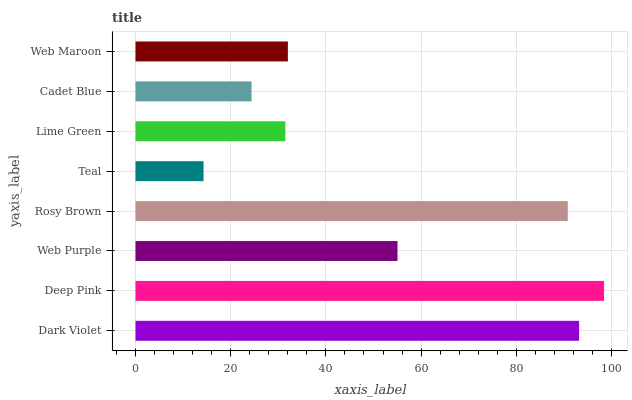Is Teal the minimum?
Answer yes or no. Yes. Is Deep Pink the maximum?
Answer yes or no. Yes. Is Web Purple the minimum?
Answer yes or no. No. Is Web Purple the maximum?
Answer yes or no. No. Is Deep Pink greater than Web Purple?
Answer yes or no. Yes. Is Web Purple less than Deep Pink?
Answer yes or no. Yes. Is Web Purple greater than Deep Pink?
Answer yes or no. No. Is Deep Pink less than Web Purple?
Answer yes or no. No. Is Web Purple the high median?
Answer yes or no. Yes. Is Web Maroon the low median?
Answer yes or no. Yes. Is Cadet Blue the high median?
Answer yes or no. No. Is Rosy Brown the low median?
Answer yes or no. No. 